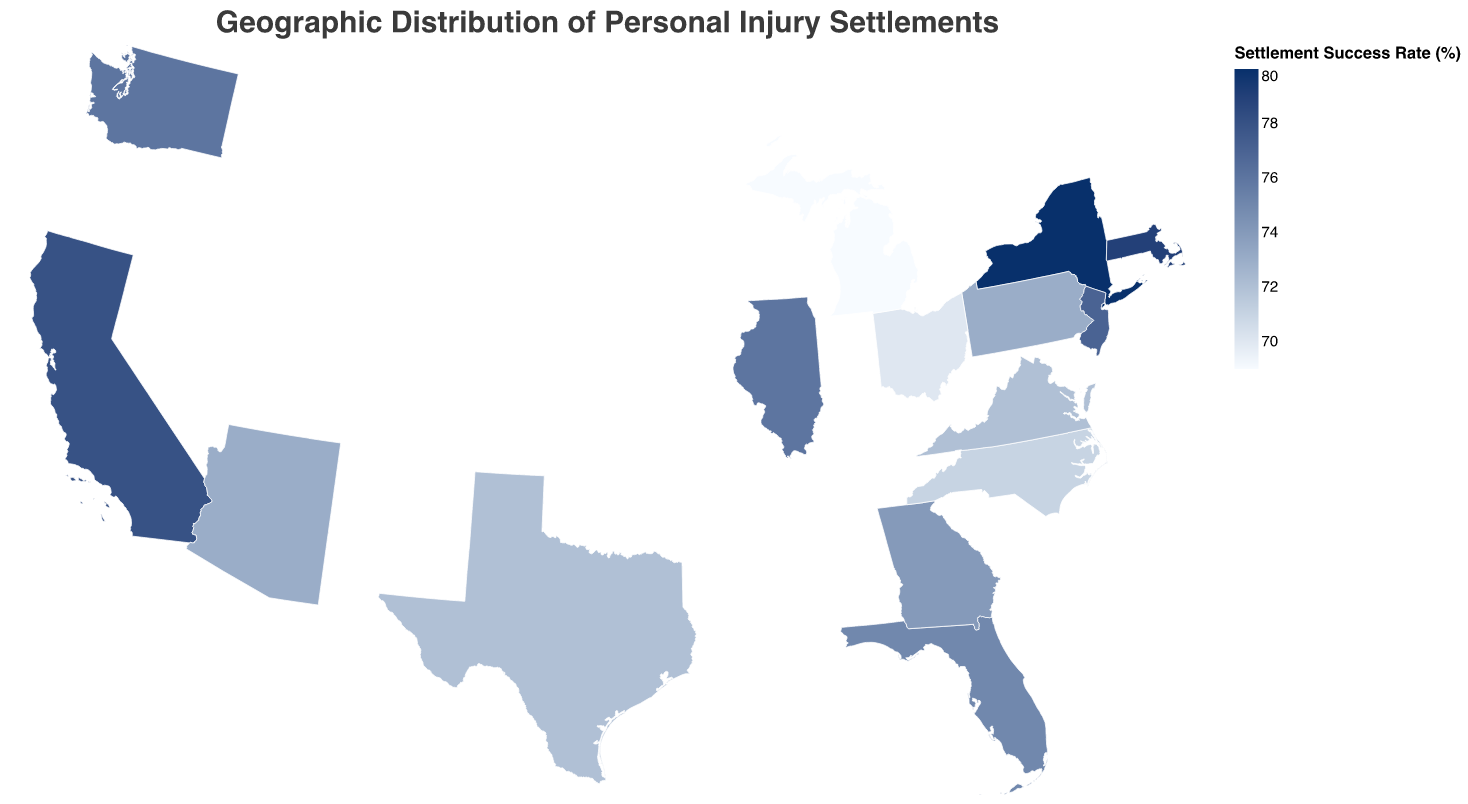What is the title of the figure? The title of the figure is found at the top and is usually the largest text in the plot. It provides a brief description of the content of the figure.
Answer: Geographic Distribution of Personal Injury Settlements Which state has the highest settlement success rate? To identify the state with the highest settlement success rate, look for the darkest color on the geographic plot. The tooltip will also display the exact percentage when hovered over the state.
Answer: New York What is the settlement success rate in California? Hovering over California on the geographical plot or checking the color legend would provide the exact settlement success rate in percentage format.
Answer: 78% Compare the settlement success rate between Illinois and Virginia. Which one is higher? By examining the color shade of Illinois and Virginia or using the tooltip, we can observe which state has a higher percentage.
Answer: Illinois What are the states with a settlement success rate of over 75%? Identify the states with the darkest shades, which correspond to rates above 75%, and confirm with hover tooltips.
Answer: California, New York, Illinois, New Jersey, Washington, Massachusetts Which state has the lowest average settlement amount? Hovering over each state and comparing the values in the tooltips, or finding the lightest colored state, will reveal the lowest average settlement amount.
Answer: Michigan How does Florida's settlement success rate compare to its average settlement amount? Referencing the tooltip for Florida, it provides both the settlement success rate and the average settlement amount for a direct comparison.
Answer: Settlement Success Rate: 75%, Average Settlement Amount: $405,000 What is the difference in the settlement success rate between Texas and Georgia? Subtract Georgia's settlement success rate from Texas' to find the difference. Texas: 72%, Georgia: 74%, so the difference is
Answer: 2% Which states exhibit an average settlement amount above $400,000? Hovering over each state and evaluating the tooltip for values above $400,000.
Answer: California, New York, New Jersey, Massachusetts Is there a correlation between the settlement success rate and the average settlement amount for these states? By examining the plot or using statistical tools, one could check if higher success rates align with higher settlement amounts, generally states with success rate near the top 75-80% also show higher average settlement amounts.
Answer: Yes, generally there is a positive correlation 